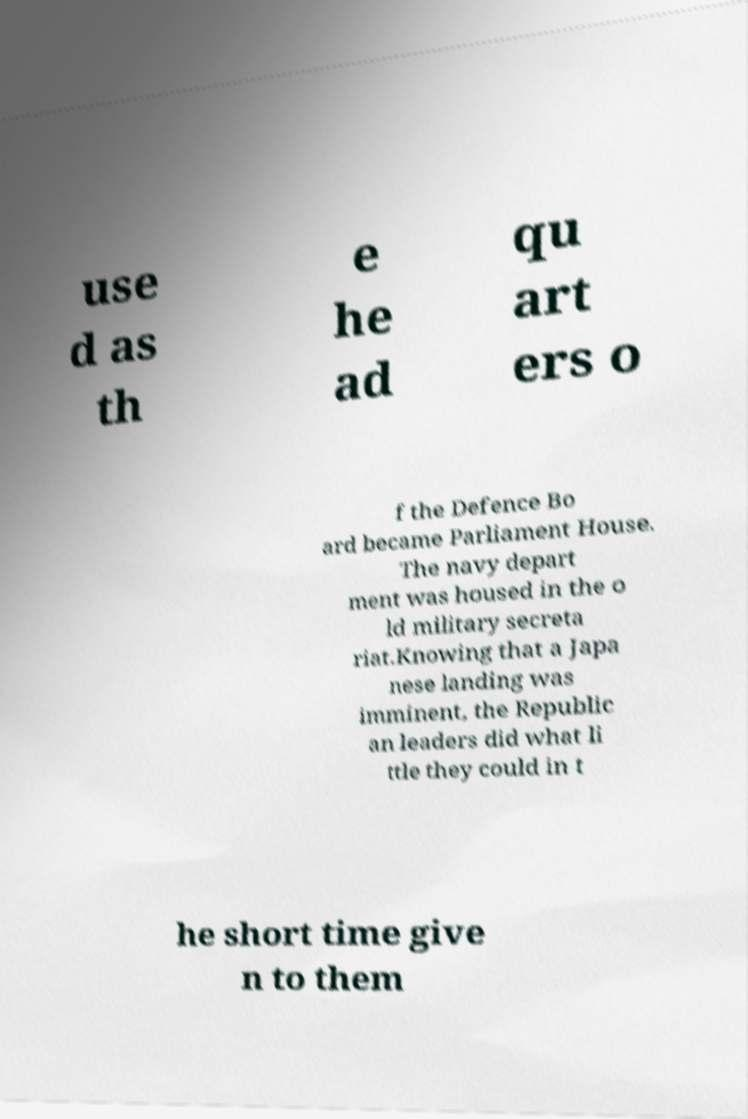Could you extract and type out the text from this image? use d as th e he ad qu art ers o f the Defence Bo ard became Parliament House. The navy depart ment was housed in the o ld military secreta riat.Knowing that a Japa nese landing was imminent, the Republic an leaders did what li ttle they could in t he short time give n to them 